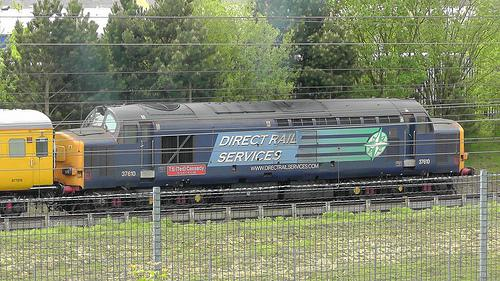Question: what is on the track?
Choices:
A. A car.
B. A person.
C. A trolly.
D. A train.
Answer with the letter. Answer: D Question: what are the chain links?
Choices:
A. A gate.
B. A fence.
C. A cage.
D. A pet crate.
Answer with the letter. Answer: B Question: how many train cars?
Choices:
A. 12.
B. 13.
C. 2.
D. 5.
Answer with the letter. Answer: C Question: what color are the trees?
Choices:
A. Brown.
B. Green.
C. Yellow.
D. Red.
Answer with the letter. Answer: B Question: what color is the fence?
Choices:
A. Black.
B. Silver.
C. White.
D. Yellow.
Answer with the letter. Answer: B 